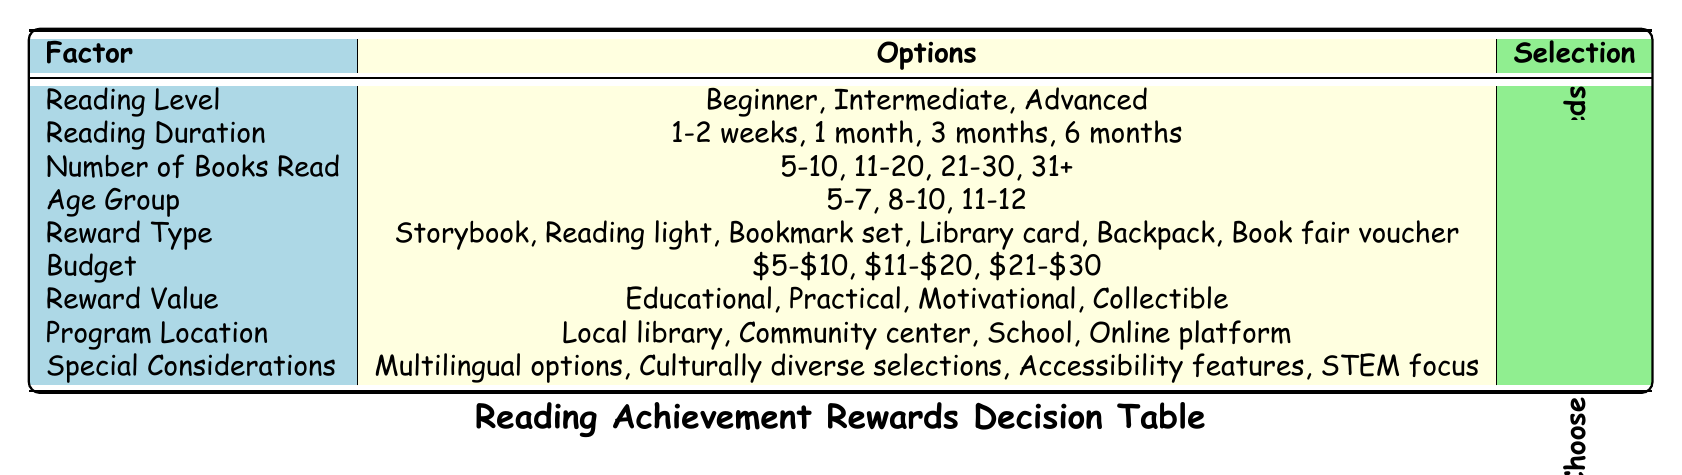What are the three reading levels mentioned in the table? The table lists three reading levels: Beginner, Intermediate, and Advanced. This information can be directly retrieved from the "Reading Level" row in the table.
Answer: Beginner, Intermediate, Advanced What is the budget range for rewards related to reading achievements? The table shows three budget ranges: $5-$10, $11-$20, and $21-$30. This is listed under the "Budget" row.
Answer: $5-$10, $11-$20, $21-$30 Is there an option for a multilingual selection of rewards? Yes, the table indicates that there is a special consideration for "Multilingual options." This is found in the "Special Considerations" section of the table.
Answer: Yes How many reward types are listed, and what is the total value of their education, practical, motivational, and collectible options? There are six reward types listed: Storybook, Reading light, Bookmark set, Library card, Backpack, and Book fair voucher. The total number of Reward Value options is four (Educational, Practical, Motivational, and Collectible). This means the count needs to be calculated individually. Thus, 6 + 4 = 10.
Answer: 10 If a child reads 11-20 books over 1 month, what reward type would be appropriate based on the table? For a child reading 11-20 books over 1 month, the reward type could include any of the available types because reading duration and number of books read both fall within the intermediate milestone. The decision would be based on the child’s needs as indicated in the table.
Answer: Depends on child's needs If a child is aged 8-10 and reads 21-30 books, which special considerations can apply? A child in the age group of 8-10 reading 21-30 books can have multiple special considerations apply: multicultural options and potentially accessibility features would be important at this reading level. These selections align with the provided special considerations.
Answer: Multilingual options, Accessibility features What is the relationship between the reading duration of 1-2 weeks and the reward types? The relationship indicates that for reading accomplishments in a relatively short duration, appropriate rewards could be any of the types listed, depending on the child's needs. Generally, this would not imply expensive rewards as the time for achievement is shorter.
Answer: Depends on child's needs Which program locations offer rewards according to the data? There are four program locations mentioned: Local library, Community center, School, and Online platform. These can be found under the "Program Location" section in the table.
Answer: Local library, Community center, School, Online platform 